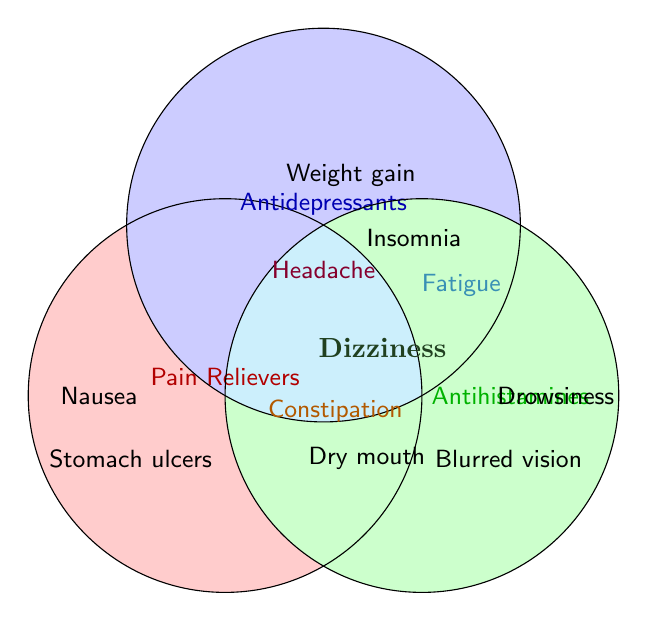What side effect is common among all three drug categories? The central part of the Venn diagram where all three circles intersect shows the shared side effect for pain relievers, antidepressants, and antihistamines. The label in this overlapping section indicates the common side effect.
Answer: Dizziness How many unique side effects are associated with antidepressants alone? The section of the Venn diagram that overlaps with only the antidepressants circle contains labels for side effects unique to this category. Count these labels.
Answer: 3 Which side effect is shared between pain relievers and antihistamines but not antidepressants? Look at the overlapping section between the pain relievers and antihistamines circles that does not include the antidepressants circle. The label in this section indicates the shared side effect.
Answer: Constipation Which drug categories share the side effect "Fatigue"? Locate the label "Fatigue" on the Venn diagram and observe which circles it lies in the overlapping area. These circles represent the drug categories sharing this side effect.
Answer: Antidepressants & Antihistamines How many shared side effects exist between pain relievers and antidepressants? Find the overlapping area between the pain relievers and antidepressants circles. Count the labels within this overlap.
Answer: 1 Are there more unique side effects for pain relievers or antihistamines? Compare the number of labels in the non-overlapping sections of both the pain relievers and antihistamines circles. The category with more labels has more unique side effects.
Answer: Pain Relievers What is a symptom that is unique to antihistamines? Look at the sections of the Venn diagram that contain only antihistamines. Any label in this section represents a unique side effect of antihistamines.
Answer: Drowsiness Which drug category has "Dry mouth" as a side effect? Locate the label "Dry mouth" within the Venn diagram and observe in which circle it lies. The circle indicates the drug category associated with this side effect.
Answer: Antidepressants How many total side effects are there when counting shared and unique side effects across all categories? Sum all unique and shared side effects by counting every label in the Venn diagram. Ensure to count each label only once even if it appears in intersection areas.
Answer: 11 